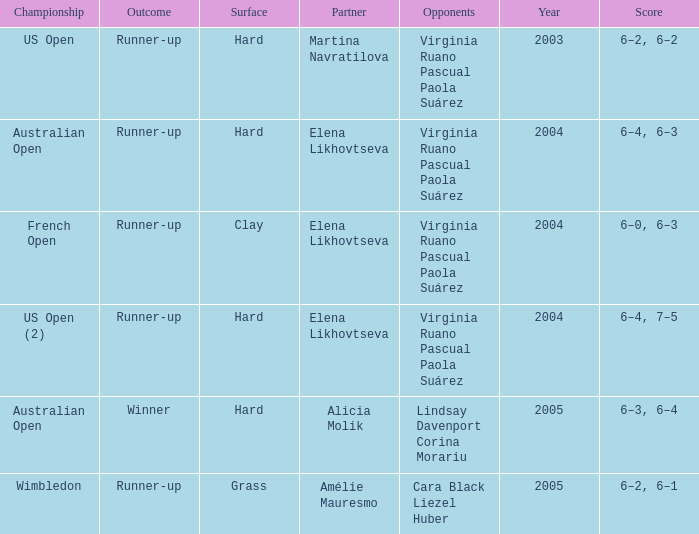When us open (2) is the championship what is the surface? Hard. 